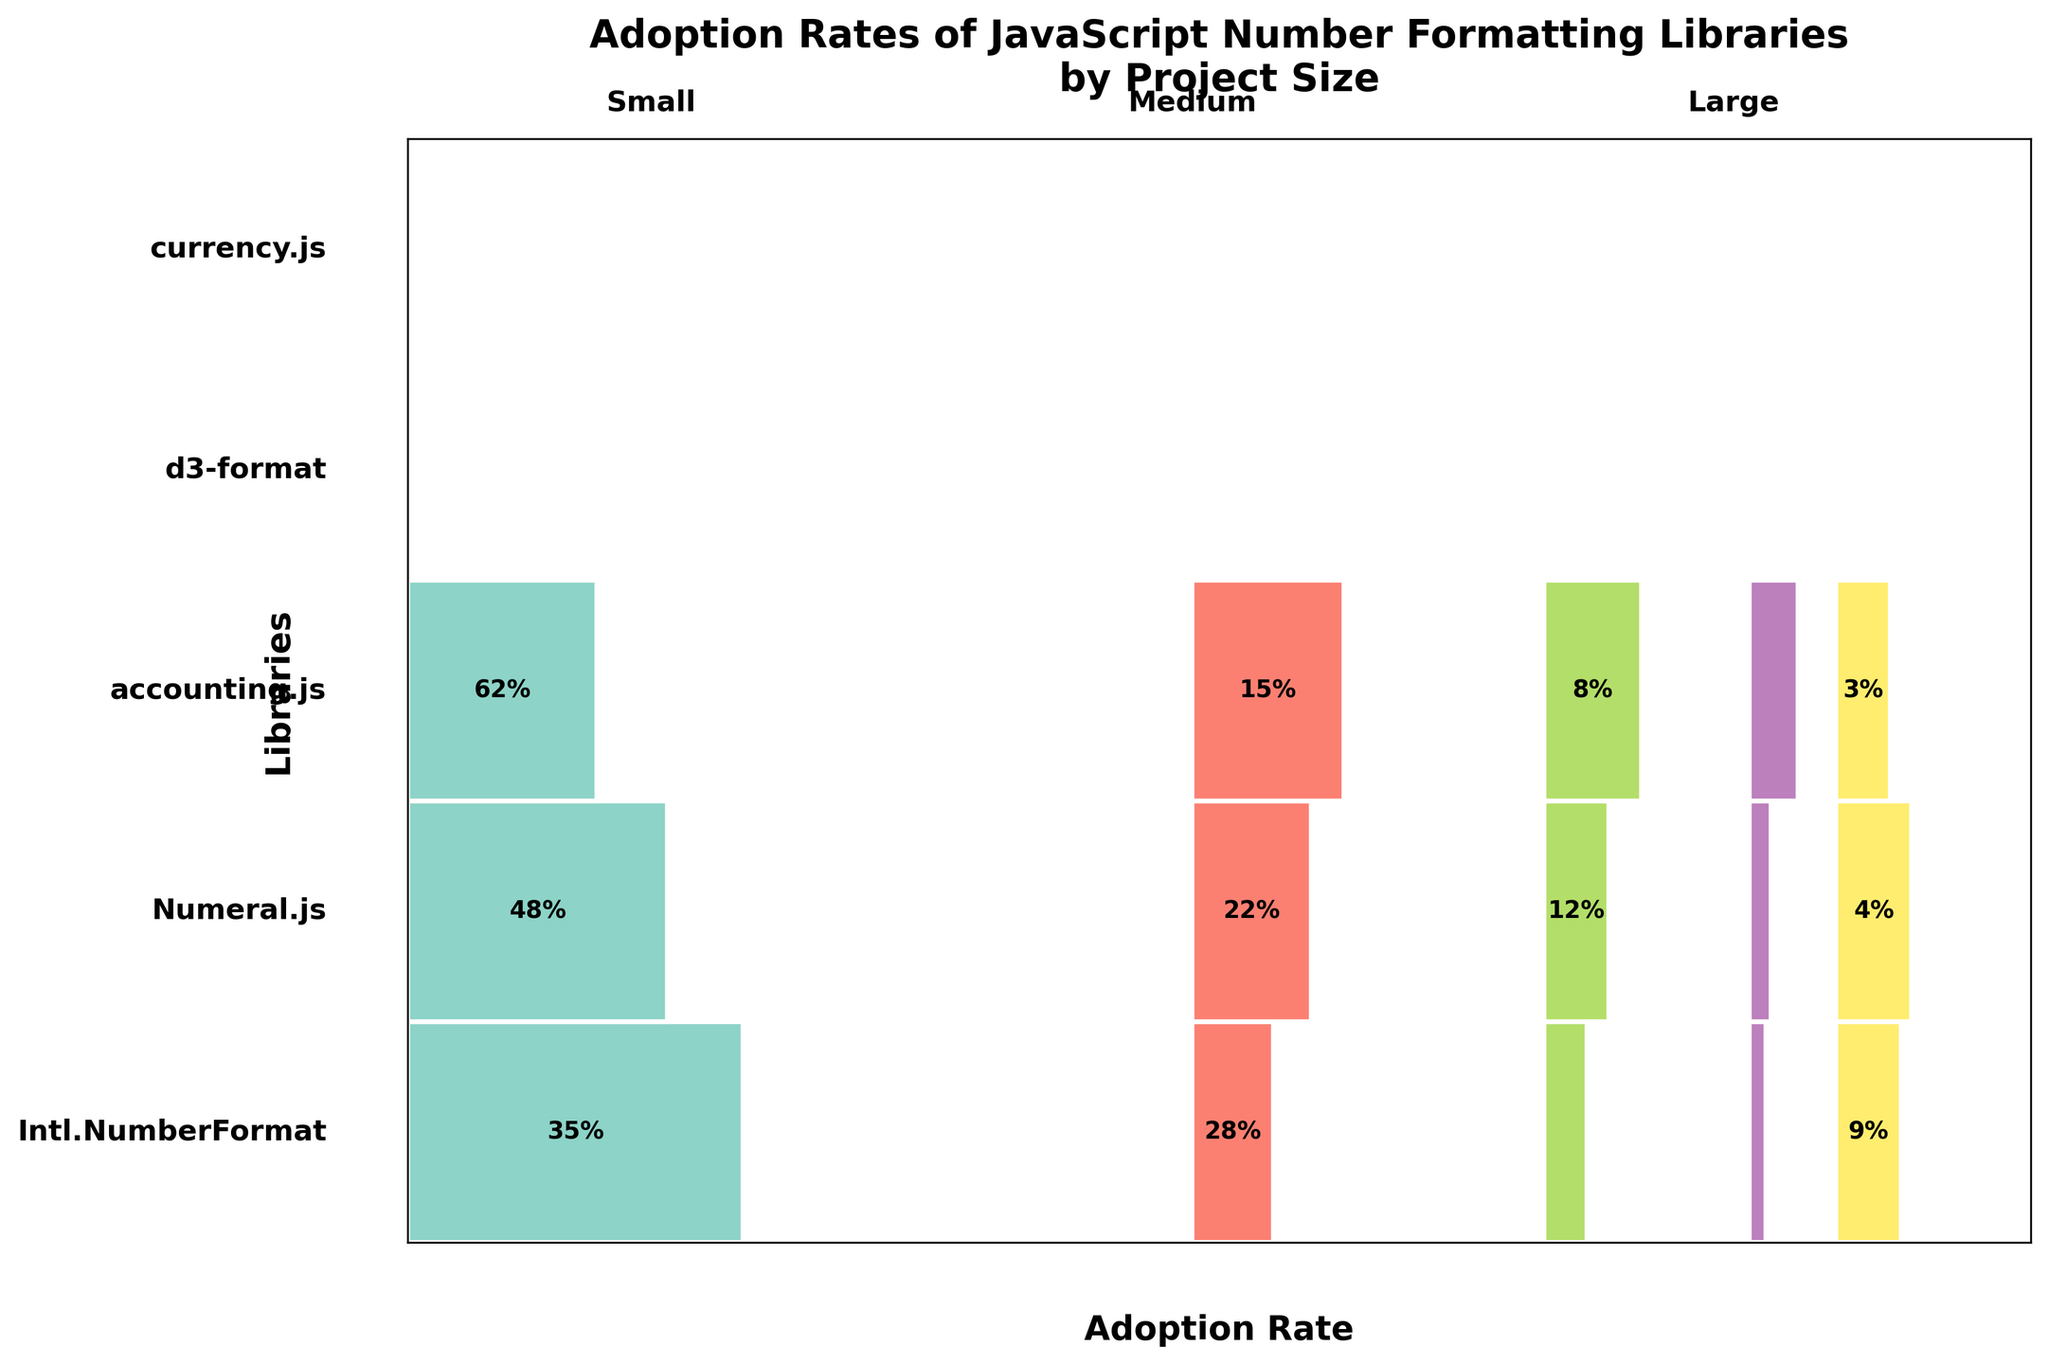what is the most adopted JavaScript number formatting library for large projects? Look at the largest visually represented section under "Large" projects. "Intl.NumberFormat" occupies the most space and has the highest percentage value shown, which is 62%.
Answer: Intl.NumberFormat which library has the lowest adoption rate for small projects? Observe the smallest visual rectangle under "Small" projects. "currency.js" has the smallest rectangle, with a 9% adoption rate indicated.
Answer: currency.js what is the overall adoption percentage difference between Numeral.js and accounting.js for medium projects? Find the adoption rates for Numeral.js and accounting.js under "Medium" projects, which are 22% and 12% respectively. Subtract 12% from 22% to get the difference.
Answer: 10% which classification (library & project size) combination has an adoption rate of 4%? Check the labels inside each rectangle. The rectangle labeled "4%" falls under "currency.js" and "Medium".
Answer: currency.js and Medium how does the adoption rate of Intl.NumberFormat for medium projects compare to the rate for small projects? Compare the values shown inside the "Intl.NumberFormat" rectangles for "Small" and "Medium" projects. The rates are 35% for Small and 48% for Medium. 48% is greater than 35%.
Answer: Medium > Small which library shows the most uniform adoption across different project sizes? Look at the shapes of the rectangles for each library across Small, Medium, and Large project sizes. "d3-format" appears to have similar-sized rectangles for each segment: 10%, 14%, and 12%.
Answer: d3-format what is the combined adoption rate of Intl.NumberFormat and accounting.js for large projects? Sum the adoption rates for Intl.NumberFormat and accounting.js under the "Large" category. 62% + 8% = 70%.
Answer: 70% which project size has the most varied adoption rates across libraries? Compare the variability in rectangle sizes for Small, Medium, and Large project sizes. The Small project size has the most visibly varied rectangles, with rates ranging from 35% down to 9%.
Answer: Small 